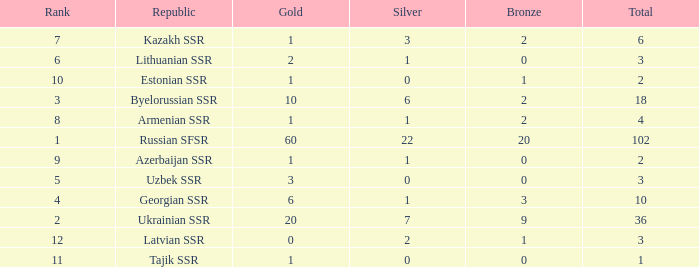What is the average total for teams with more than 1 gold, ranked over 3 and more than 3 bronze? None. 